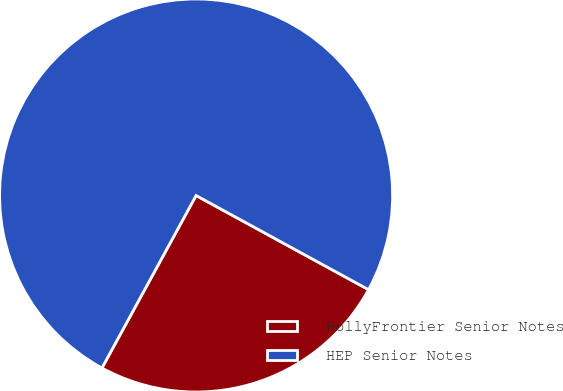Convert chart to OTSL. <chart><loc_0><loc_0><loc_500><loc_500><pie_chart><fcel>HollyFrontier Senior Notes<fcel>HEP Senior Notes<nl><fcel>25.0%<fcel>75.0%<nl></chart> 